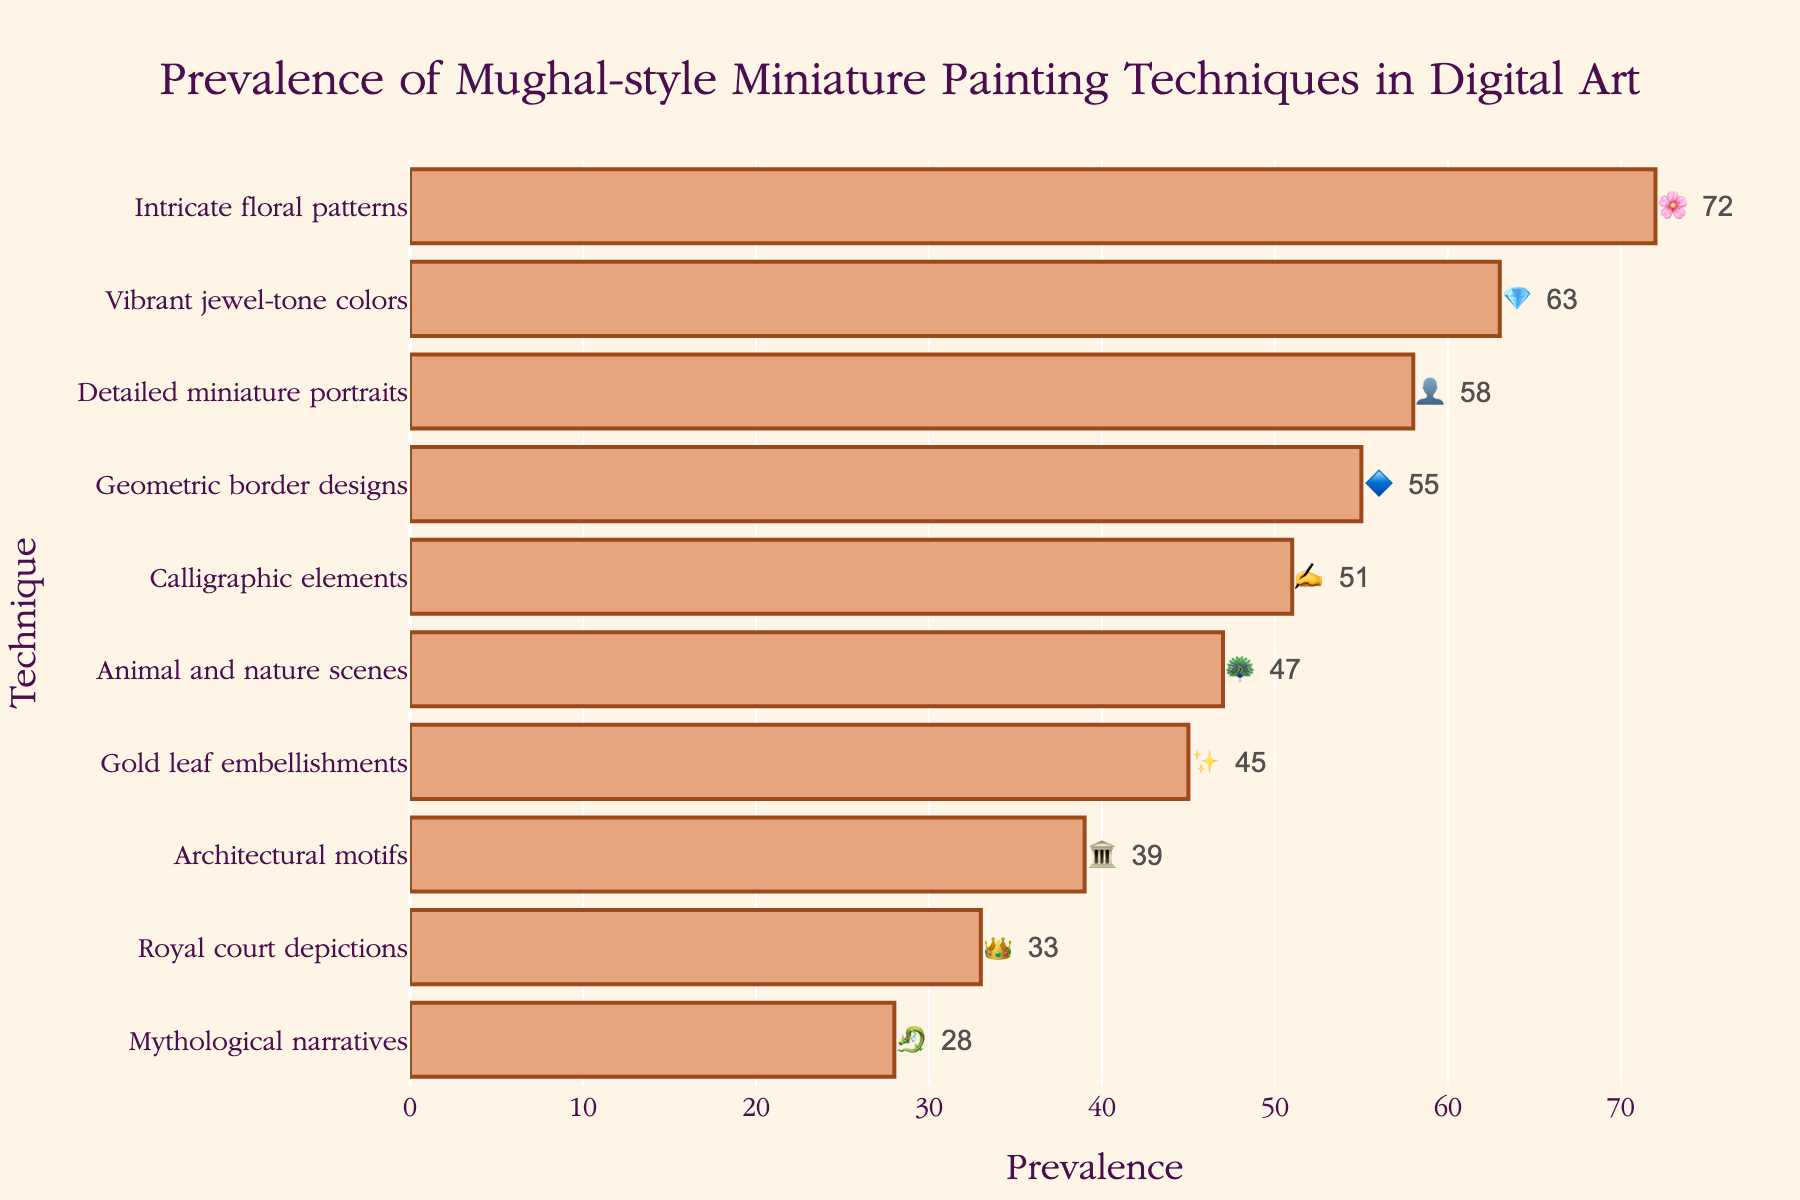What's the most prevalent Mughal-style technique in digital art? The title indicates the data represents the prevalence of various Mughal-style techniques in digital art. By looking at the figure, the technique with the highest value in the Prevalence axis is "Intricate floral patterns" with a value of 72.
Answer: Intricate floral patterns Which technique is represented by the 🌸 emoji, and what is its prevalence? By inspecting the chart, the technique associated with the 🌸 emoji is "Intricate floral patterns," and its prevalence value is 72, as indicated by the text labels on the bars.
Answer: Intricate floral patterns and 72 How many techniques have a prevalence greater than 50? By visually scanning the prevalence values on the x-axis, the following techniques have values greater than 50: Intricate floral patterns (72), Vibrant jewel-tone colors (63), Detailed miniature portraits (58), Geometric border designs (55), and Calligraphic elements (51). Five techniques meet this criterion.
Answer: 5 What is the combined prevalence of "Gold leaf embellishments" and "Architectural motifs"? The values for "Gold leaf embellishments" and "Architectural motifs" are 45 and 39 respectively. Adding these two values, 45 + 39 equals 84.
Answer: 84 Which technique associated with the 🐉 emoji has the lowest prevalence? Scanning for the 🐉 emoji, it is associated with "Mythological narratives," which has a prevalence value of 28, making it the technique with the lowest prevalence in the chart.
Answer: Mythological narratives How much more prevalent are “Vibrant jewel-tone colors” compared to “Animal and nature scenes”? Identify the values for both techniques: "Vibrant jewel-tone colors" has a prevalence of 63, while "Animal and nature scenes" has a prevalence of 47. Subtract the lower value from the higher value: 63 - 47 equals 16.
Answer: 16 Which technique is least prevalent and what is the corresponding emoji? By examining the bar with the smallest prevalence value, "Mythological narratives" is the least prevalent with a value of 28. The corresponding emoji is 🐉.
Answer: Mythological narratives and 🐉 What is the median prevalence of the techniques listed? To find the median, sort the values: 28, 33, 39, 45, 47, 51, 55, 58, 63, 72. Since there are 10 values, the median will be the average of the 5th and 6th values. Thus, (47 + 51) / 2 equals 49.
Answer: 49 Which technique has a prevalence closest to the average prevalence of all techniques? Calculate the average prevalence by summing all values (total is 491) and dividing by the number of techniques (10). The average is 491 / 10, which equals 49.1. The closest prevalence to this is 47 for "Animal and nature scenes."
Answer: Animal and nature scenes 